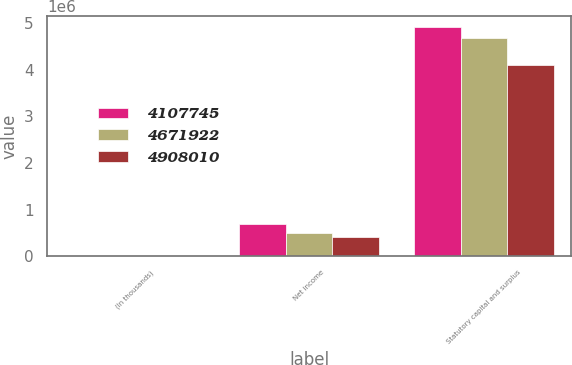Convert chart to OTSL. <chart><loc_0><loc_0><loc_500><loc_500><stacked_bar_chart><ecel><fcel>(In thousands)<fcel>Net income<fcel>Statutory capital and surplus<nl><fcel>4.10774e+06<fcel>2013<fcel>680418<fcel>4.90801e+06<nl><fcel>4.67192e+06<fcel>2012<fcel>490119<fcel>4.67192e+06<nl><fcel>4.90801e+06<fcel>2011<fcel>417441<fcel>4.10774e+06<nl></chart> 